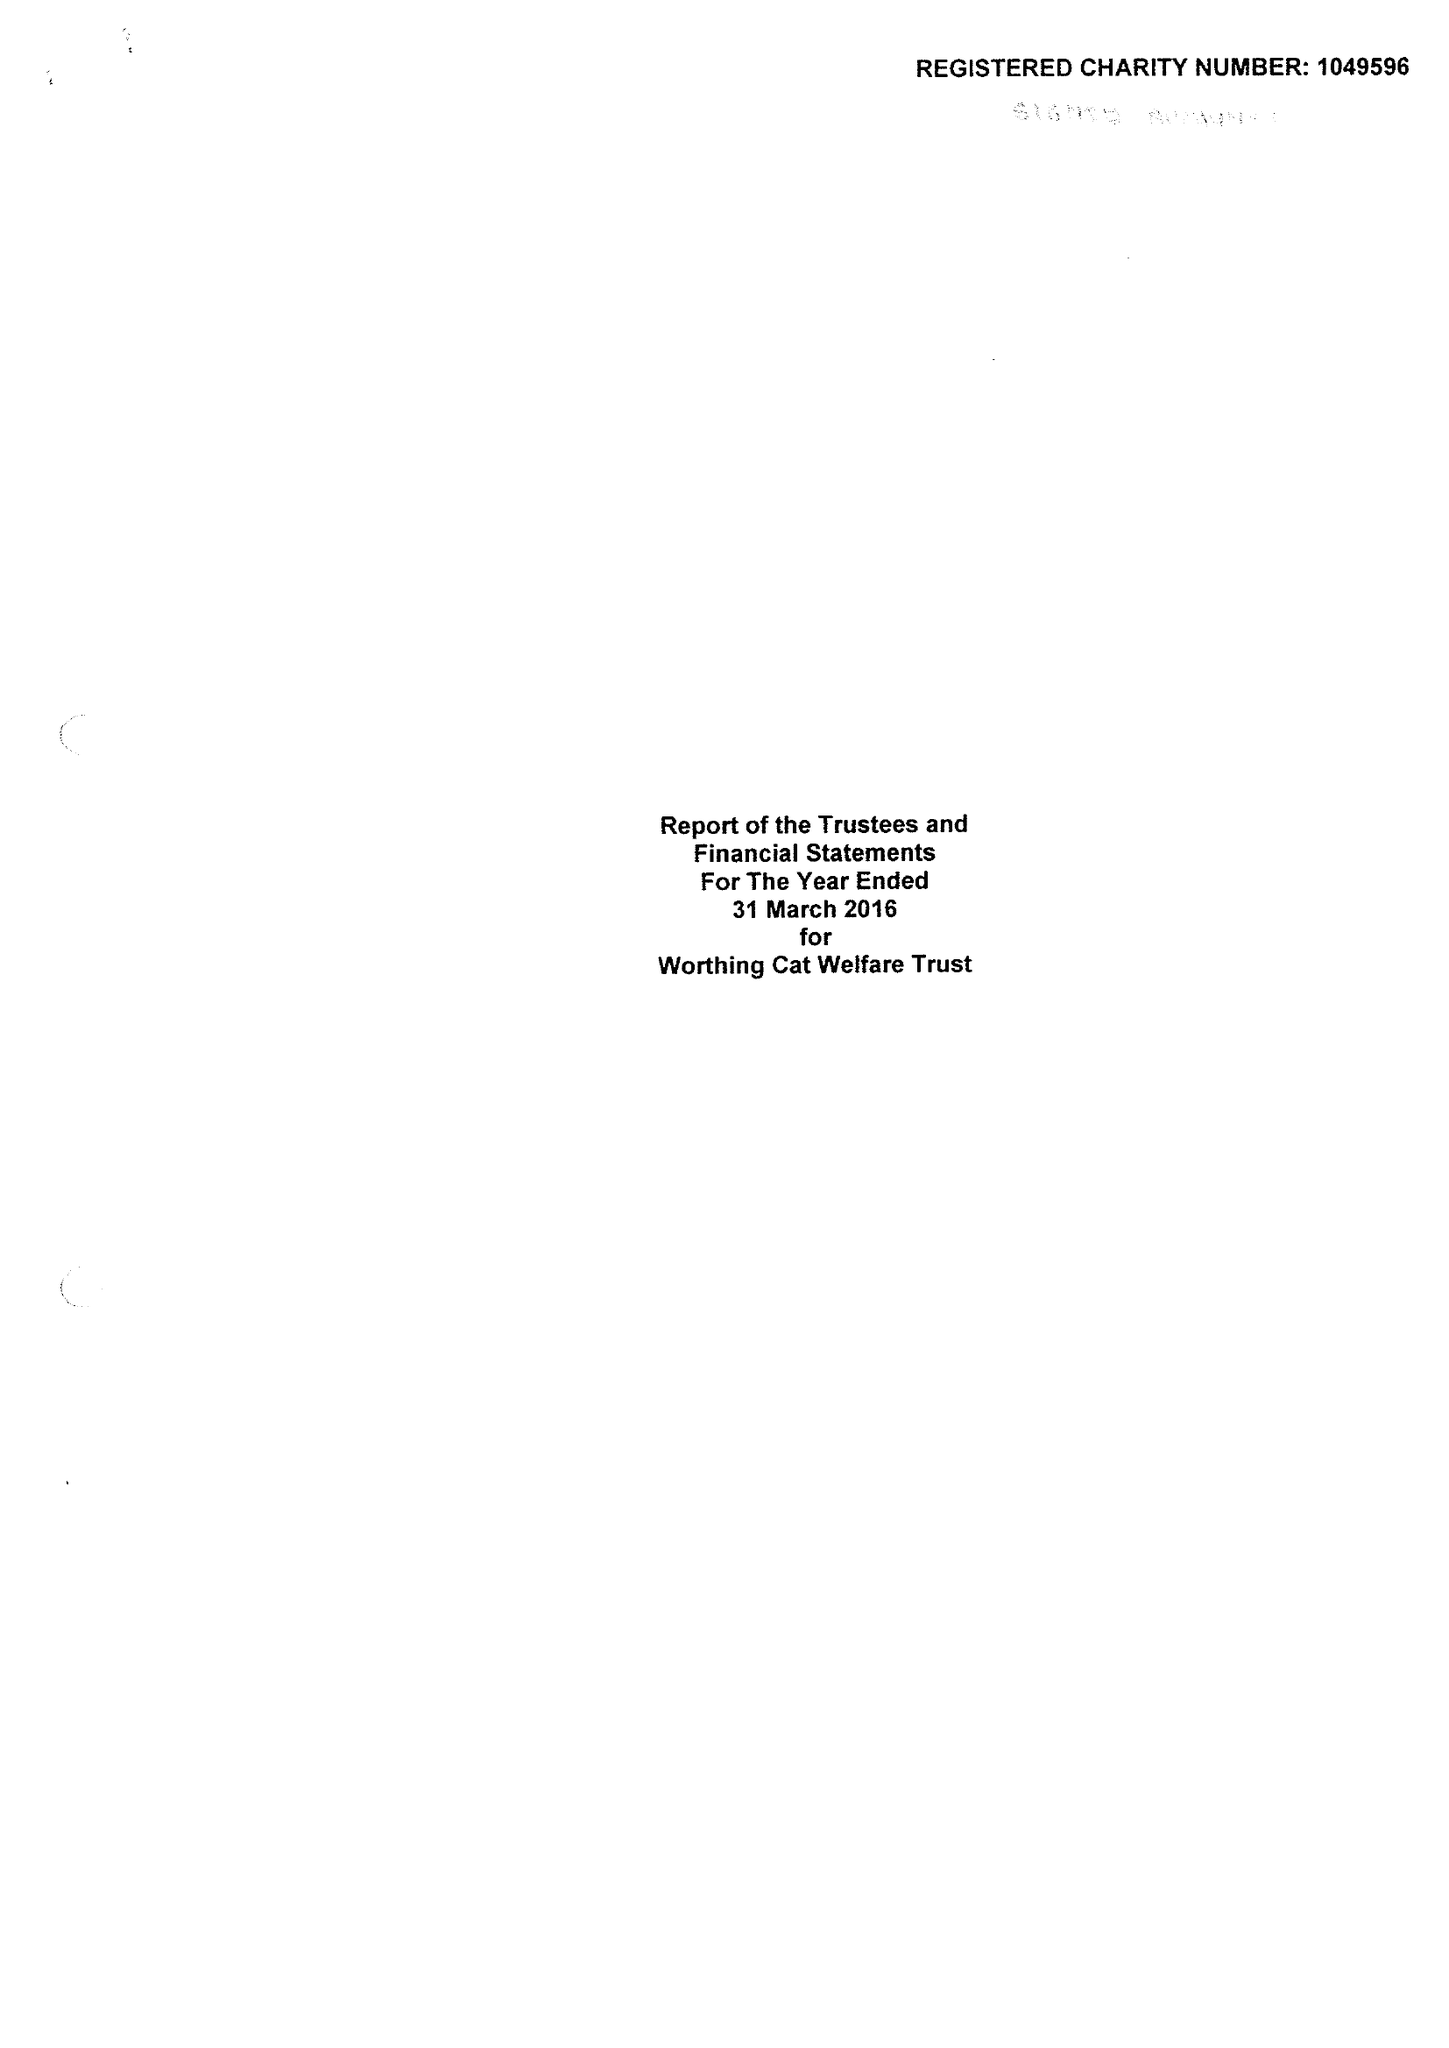What is the value for the address__post_town?
Answer the question using a single word or phrase. WORTHING 